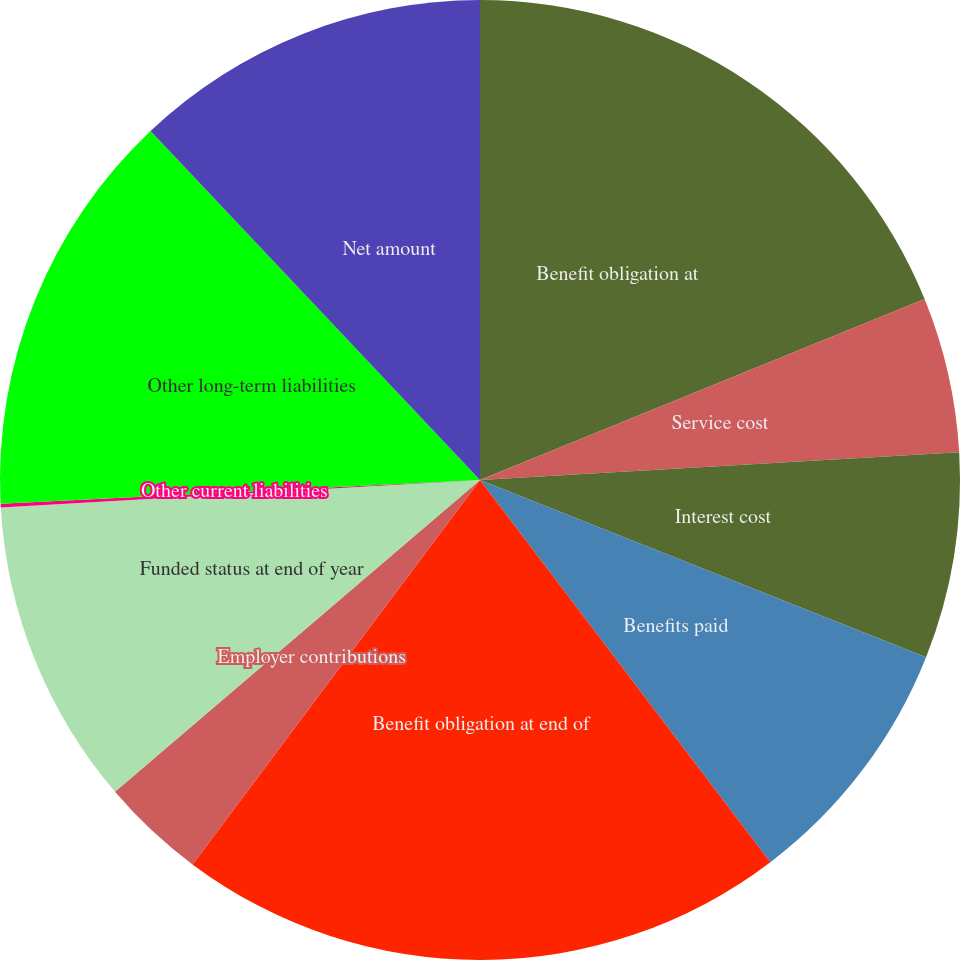Convert chart to OTSL. <chart><loc_0><loc_0><loc_500><loc_500><pie_chart><fcel>Benefit obligation at<fcel>Service cost<fcel>Interest cost<fcel>Benefits paid<fcel>Benefit obligation at end of<fcel>Employer contributions<fcel>Funded status at end of year<fcel>Other current liabilities<fcel>Other long-term liabilities<fcel>Net amount<nl><fcel>18.85%<fcel>5.23%<fcel>6.94%<fcel>8.64%<fcel>20.56%<fcel>3.53%<fcel>10.34%<fcel>0.12%<fcel>13.75%<fcel>12.04%<nl></chart> 